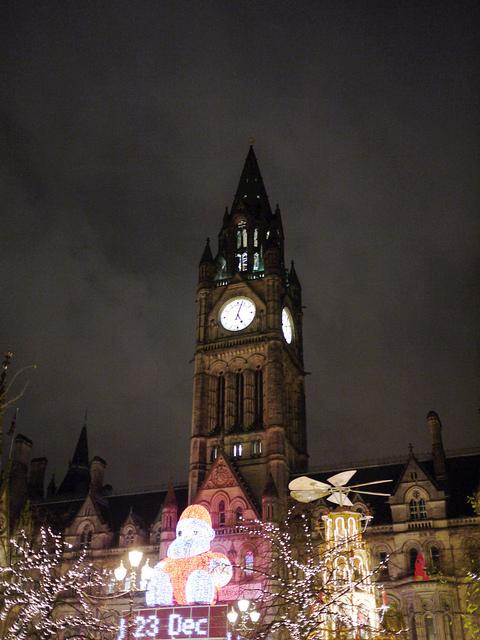Is there a light on in the tower?
Keep it brief. Yes. What time is it?
Be succinct. 5:05. What time of the year was this picture taken?
Short answer required. Christmas. 